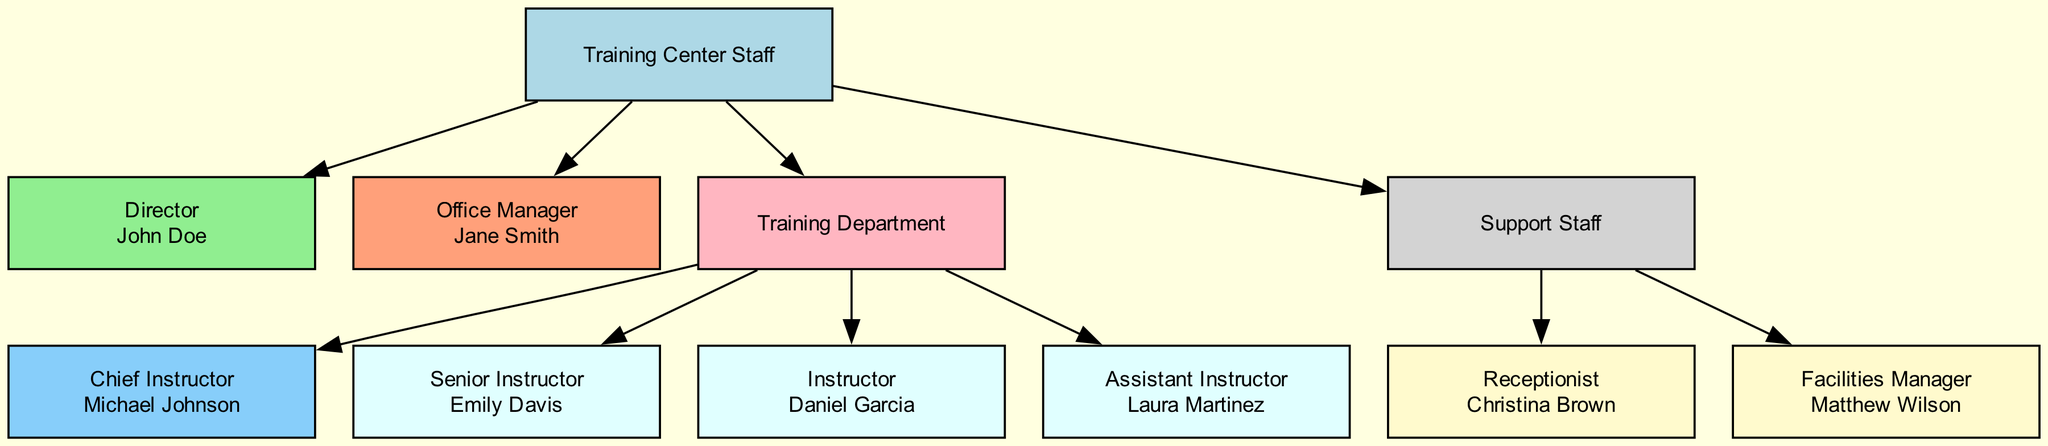What is the title of the Director? The diagram shows the Director's node, which contains the title "Director" along with the name "John Doe." This confirms that the title is clearly displayed in that node.
Answer: Director Who is the Chief Instructor? The Chief Instructor's node contains the title "Chief Instructor" and the name "Michael Johnson." By examining this node, we can identify the person holding the position as mentioned.
Answer: Michael Johnson How many Instructors are there in the Training Department? In the diagram, the Training Department node connects to three Instructor nodes. By counting these connections, we can find the total number of Instructors.
Answer: 3 What are the responsibilities of the Office Manager? The Office Manager is represented in the Administrative Staff node with responsibilities listed as "Administrative tasks, scheduling, and customer relations." This information can be directly viewed in the node's text.
Answer: Administrative tasks, scheduling, and customer relations Which staff member is responsible for front desk operations? The Receptionist node shows the title "Receptionist" and the name "Christina Brown," with the responsibilities explicitly stated as "Front desk operations and customer assistance." By looking at this staff member's node, we can find the answer.
Answer: Christina Brown Who oversees the entire management of the training center? The diagram indicates that the Director's role includes "Overall management and strategic decision making." Therefore, we can deduce that the Director is responsible for overseeing the operations of the training center.
Answer: John Doe Which department includes the Assistant Instructor? The Assistant Instructor is listed under the Training Department section of the diagram, and the Instructors are connected to this department. This leads us to conclude that the Assistant Instructor is part of the Training Department.
Answer: Training Department What is the title of the member of Support Staff responsible for maintenance? The Support Staff member responsible for maintenance is identified as the "Facilities Manager," who is mentioned in the list of Support Staff members. Therefore, there is a direct link to the title displayed in that node.
Answer: Facilities Manager 